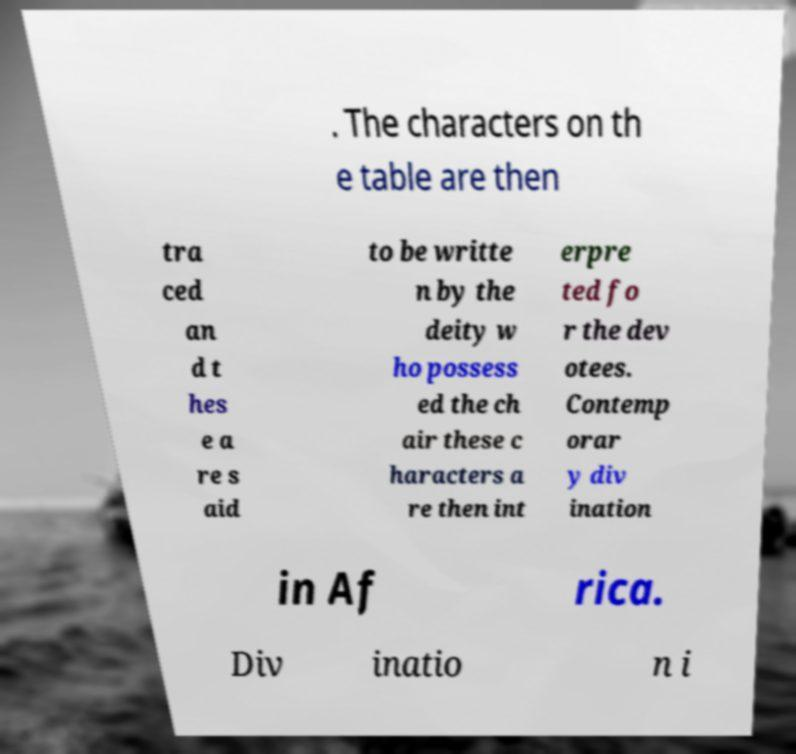For documentation purposes, I need the text within this image transcribed. Could you provide that? . The characters on th e table are then tra ced an d t hes e a re s aid to be writte n by the deity w ho possess ed the ch air these c haracters a re then int erpre ted fo r the dev otees. Contemp orar y div ination in Af rica. Div inatio n i 